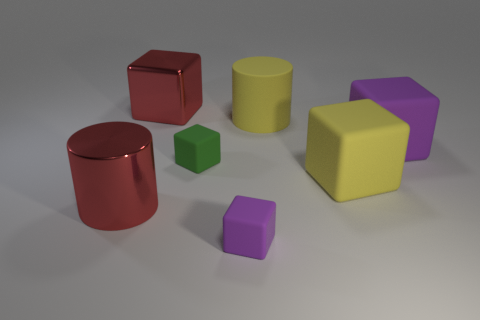Add 2 big purple matte things. How many objects exist? 9 Subtract all green cylinders. How many purple cubes are left? 2 Subtract all small matte blocks. How many blocks are left? 3 Subtract all red cylinders. How many cylinders are left? 1 Subtract 1 blocks. How many blocks are left? 4 Subtract 0 gray blocks. How many objects are left? 7 Subtract all cylinders. How many objects are left? 5 Subtract all brown blocks. Subtract all green spheres. How many blocks are left? 5 Subtract all tiny green matte cubes. Subtract all red blocks. How many objects are left? 5 Add 6 red metal things. How many red metal things are left? 8 